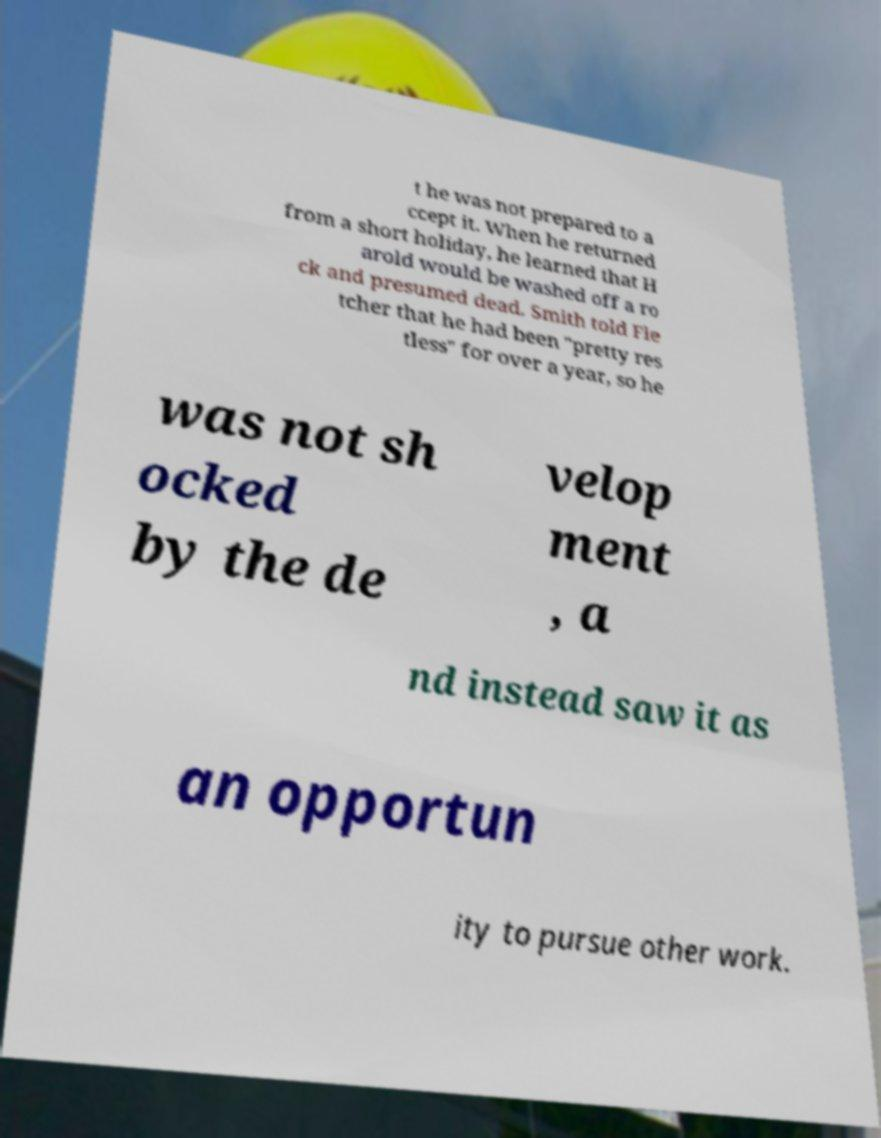Please identify and transcribe the text found in this image. t he was not prepared to a ccept it. When he returned from a short holiday, he learned that H arold would be washed off a ro ck and presumed dead. Smith told Fle tcher that he had been "pretty res tless" for over a year, so he was not sh ocked by the de velop ment , a nd instead saw it as an opportun ity to pursue other work. 